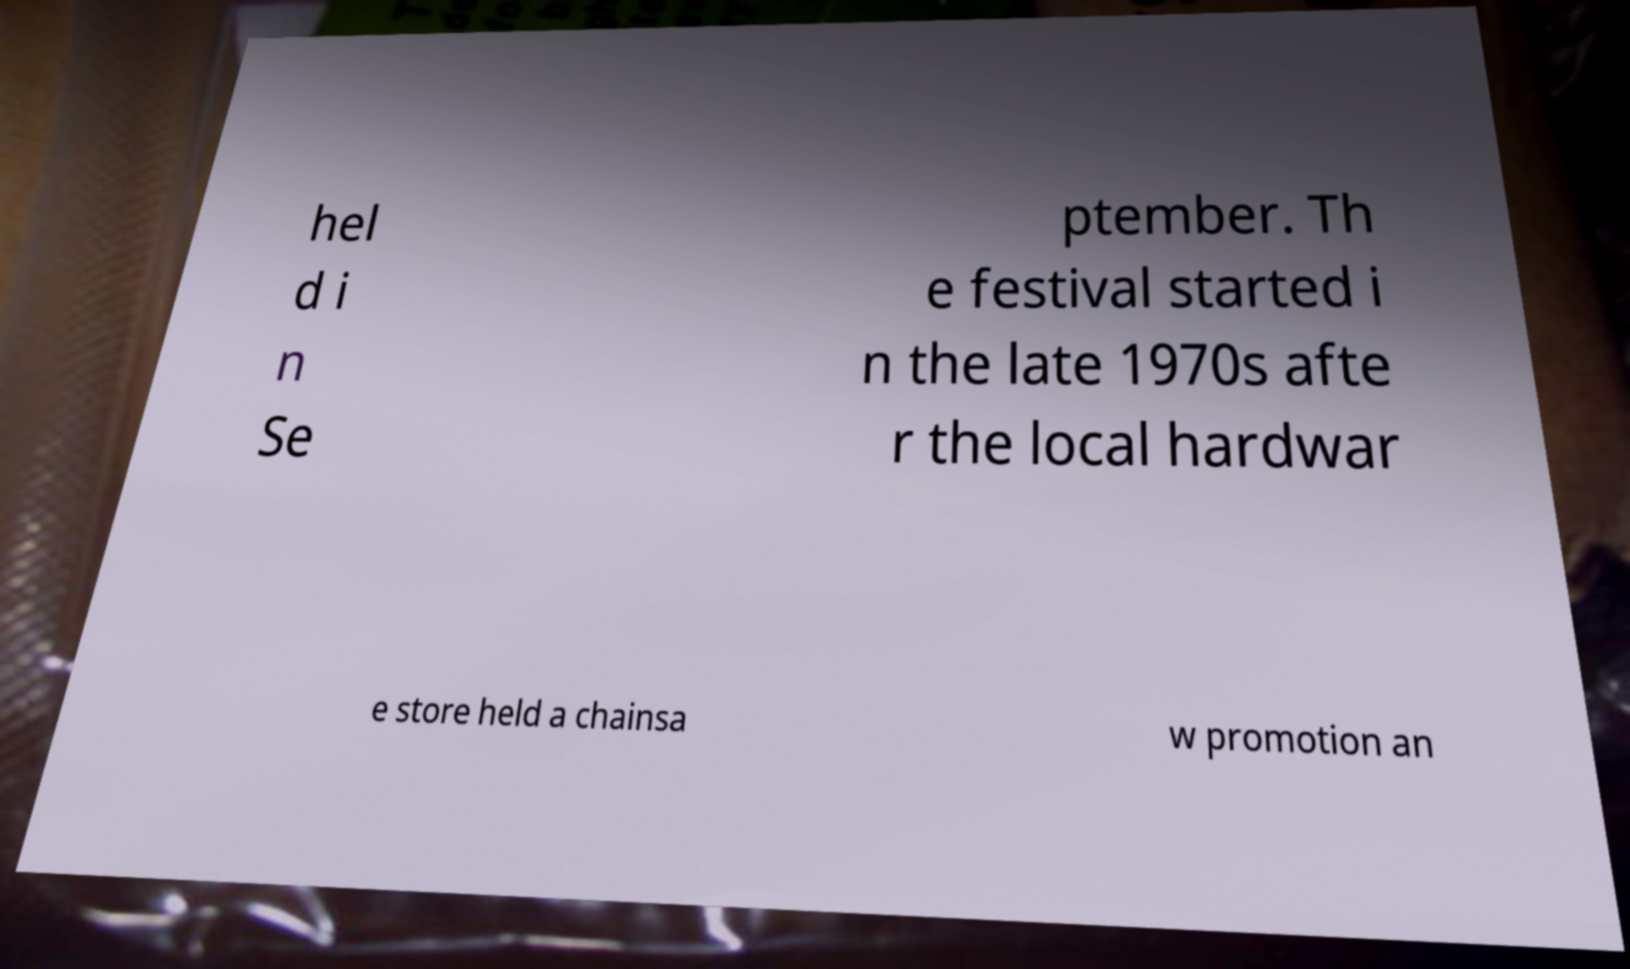Please read and relay the text visible in this image. What does it say? hel d i n Se ptember. Th e festival started i n the late 1970s afte r the local hardwar e store held a chainsa w promotion an 